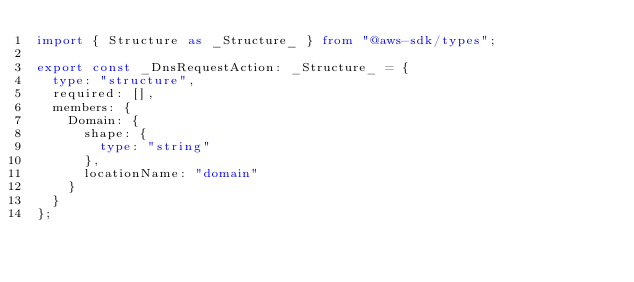<code> <loc_0><loc_0><loc_500><loc_500><_TypeScript_>import { Structure as _Structure_ } from "@aws-sdk/types";

export const _DnsRequestAction: _Structure_ = {
  type: "structure",
  required: [],
  members: {
    Domain: {
      shape: {
        type: "string"
      },
      locationName: "domain"
    }
  }
};
</code> 